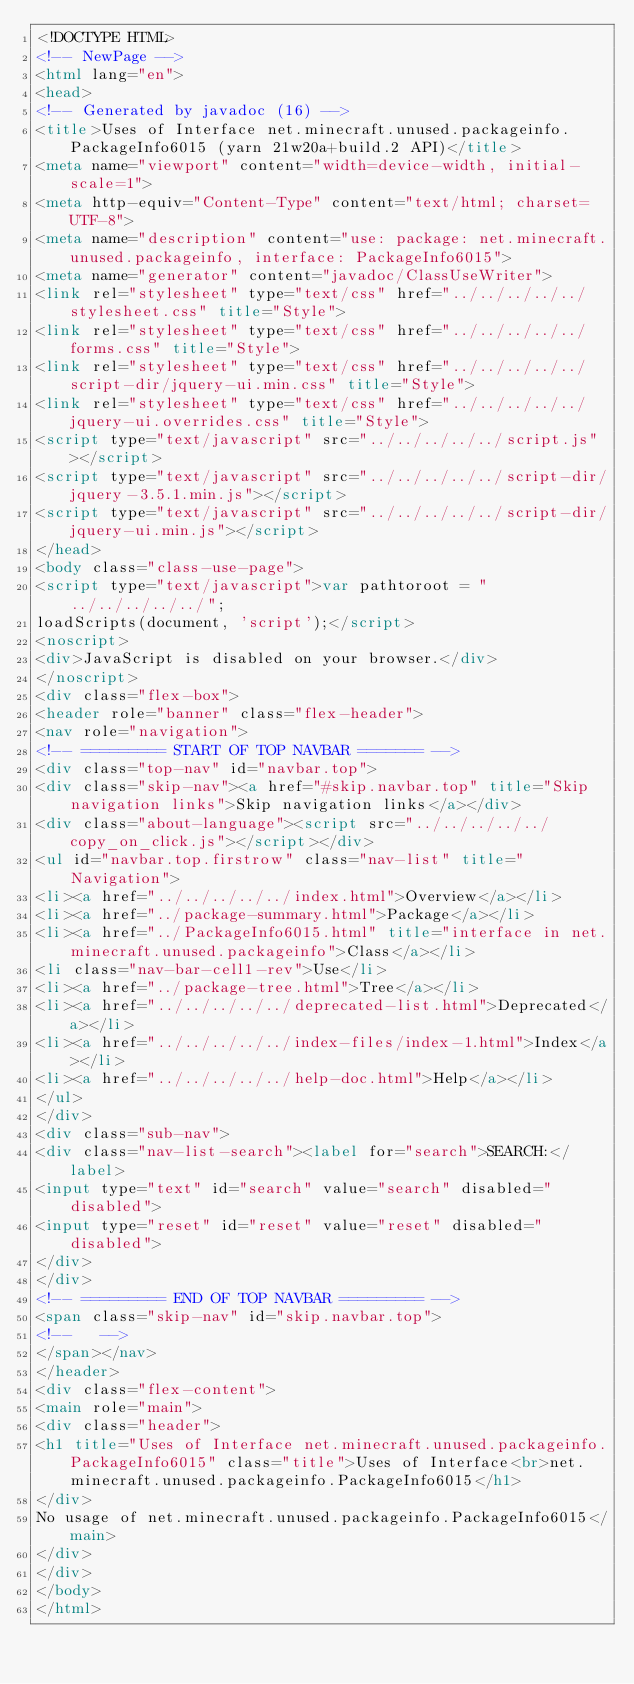Convert code to text. <code><loc_0><loc_0><loc_500><loc_500><_HTML_><!DOCTYPE HTML>
<!-- NewPage -->
<html lang="en">
<head>
<!-- Generated by javadoc (16) -->
<title>Uses of Interface net.minecraft.unused.packageinfo.PackageInfo6015 (yarn 21w20a+build.2 API)</title>
<meta name="viewport" content="width=device-width, initial-scale=1">
<meta http-equiv="Content-Type" content="text/html; charset=UTF-8">
<meta name="description" content="use: package: net.minecraft.unused.packageinfo, interface: PackageInfo6015">
<meta name="generator" content="javadoc/ClassUseWriter">
<link rel="stylesheet" type="text/css" href="../../../../../stylesheet.css" title="Style">
<link rel="stylesheet" type="text/css" href="../../../../../forms.css" title="Style">
<link rel="stylesheet" type="text/css" href="../../../../../script-dir/jquery-ui.min.css" title="Style">
<link rel="stylesheet" type="text/css" href="../../../../../jquery-ui.overrides.css" title="Style">
<script type="text/javascript" src="../../../../../script.js"></script>
<script type="text/javascript" src="../../../../../script-dir/jquery-3.5.1.min.js"></script>
<script type="text/javascript" src="../../../../../script-dir/jquery-ui.min.js"></script>
</head>
<body class="class-use-page">
<script type="text/javascript">var pathtoroot = "../../../../../";
loadScripts(document, 'script');</script>
<noscript>
<div>JavaScript is disabled on your browser.</div>
</noscript>
<div class="flex-box">
<header role="banner" class="flex-header">
<nav role="navigation">
<!-- ========= START OF TOP NAVBAR ======= -->
<div class="top-nav" id="navbar.top">
<div class="skip-nav"><a href="#skip.navbar.top" title="Skip navigation links">Skip navigation links</a></div>
<div class="about-language"><script src="../../../../../copy_on_click.js"></script></div>
<ul id="navbar.top.firstrow" class="nav-list" title="Navigation">
<li><a href="../../../../../index.html">Overview</a></li>
<li><a href="../package-summary.html">Package</a></li>
<li><a href="../PackageInfo6015.html" title="interface in net.minecraft.unused.packageinfo">Class</a></li>
<li class="nav-bar-cell1-rev">Use</li>
<li><a href="../package-tree.html">Tree</a></li>
<li><a href="../../../../../deprecated-list.html">Deprecated</a></li>
<li><a href="../../../../../index-files/index-1.html">Index</a></li>
<li><a href="../../../../../help-doc.html">Help</a></li>
</ul>
</div>
<div class="sub-nav">
<div class="nav-list-search"><label for="search">SEARCH:</label>
<input type="text" id="search" value="search" disabled="disabled">
<input type="reset" id="reset" value="reset" disabled="disabled">
</div>
</div>
<!-- ========= END OF TOP NAVBAR ========= -->
<span class="skip-nav" id="skip.navbar.top">
<!--   -->
</span></nav>
</header>
<div class="flex-content">
<main role="main">
<div class="header">
<h1 title="Uses of Interface net.minecraft.unused.packageinfo.PackageInfo6015" class="title">Uses of Interface<br>net.minecraft.unused.packageinfo.PackageInfo6015</h1>
</div>
No usage of net.minecraft.unused.packageinfo.PackageInfo6015</main>
</div>
</div>
</body>
</html>
</code> 